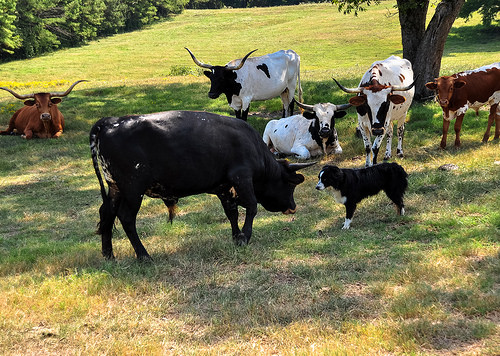<image>
Is the tree in the grass? Yes. The tree is contained within or inside the grass, showing a containment relationship. Where is the dog in relation to the cow? Is it behind the cow? No. The dog is not behind the cow. From this viewpoint, the dog appears to be positioned elsewhere in the scene. Is the dog in front of the bull? Yes. The dog is positioned in front of the bull, appearing closer to the camera viewpoint. Is the dog to the left of the bull? No. The dog is not to the left of the bull. From this viewpoint, they have a different horizontal relationship. 